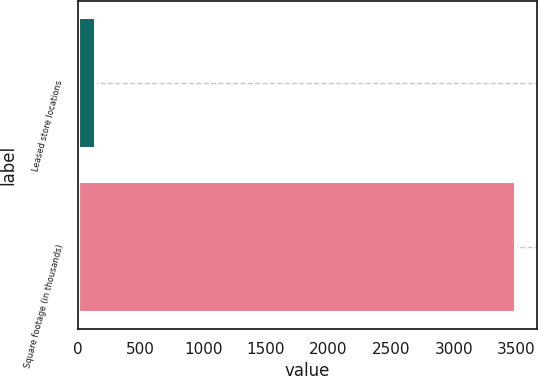Convert chart. <chart><loc_0><loc_0><loc_500><loc_500><bar_chart><fcel>Leased store locations<fcel>Square footage (in thousands)<nl><fcel>133<fcel>3493<nl></chart> 